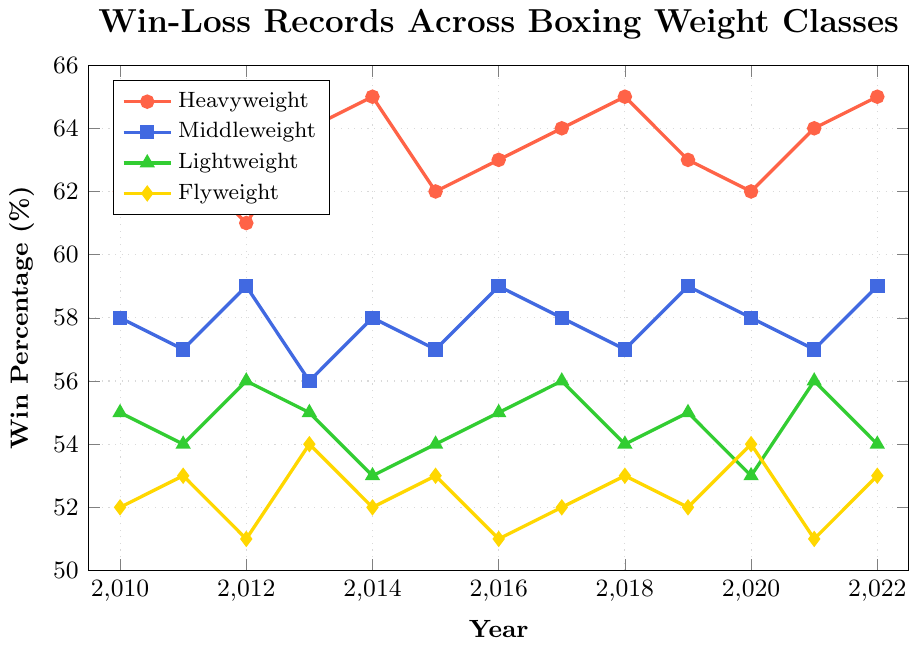Which weight class had the highest win percentage in 2016? The highest win percentage in 2016 can be seen by looking at the peaks in the graph. The Heavyweight class reached 63%, which is higher than all other classes.
Answer: Heavyweight Which weight class had the most consistent win percentage across the years? Consistency is indicated by less fluctuation over the years. The Flyweight class consistently shows win percentages between 51% and 54%, implying the least variation.
Answer: Flyweight Which weight class had the lowest win percentage in 2012, and what was it? To find the lowest win percentage in 2012, compare the points for all weight classes in that year. The Flyweight class had the lowest win percentage at 51%.
Answer: Flyweight, 51% By how much did the Heavyweight win percentage change from 2010 to 2022? Subtract the win percentage in 2010 from the win percentage in 2022 for the Heavyweight class. The values are 65% in 2022 and 62% in 2010, so the change is 65% - 62% = 3%.
Answer: 3% In which year did the Middleweight class have its lowest win percentage and what was it? Examine the graph for the lowest point in the Middleweight line. The lowest win percentage occurs in 2013 at 56%.
Answer: 2013, 56% How many times did the Flyweight class achieve a win percentage of over 52%? Count the number of years where the Flyweight line surpasses the 52% mark. This happens in 2011, 2013, 2015, 2018, 2020, and 2022, so 6 times in total.
Answer: 6 Compare the win percentage of Lightweight and Flyweight in 2021. Which class had a higher percentage and by how much? Compare the values shown for 2021. Lightweight had 56% and Flyweight had 51%, so Lightweight had a higher percentage by 56% - 51% = 5%.
Answer: Lightweight, 5% What's the average win percentage for Middleweight from 2010 to 2022 inclusive? Add all the win percentages for the Middleweight class from 2010 to 2022 and then divide by the number of years (13). The sum is \(58 + 57 + 59 + 56 + 58 + 57 + 59 + 58 + 57 + 59 + 58 + 57 + 59 = 732\). Average is \(732/13 ≈ 56.3%\).
Answer: 56.3% Which two classes showed the same win percentage at any point, and when? Compare the data points for all classes. In 2013, both Lightweight and Flyweight showed the same win percentage of 54%.
Answer: Lightweight and Flyweight, 2013 In which years was the Heavyweight win percentage exactly 63%? Identify and list the years where the Heavyweight class achieves exactly 63% on the graph. The answers are 2011, 2016, 2019, and 2021.
Answer: 2011, 2016, 2019, 2021 